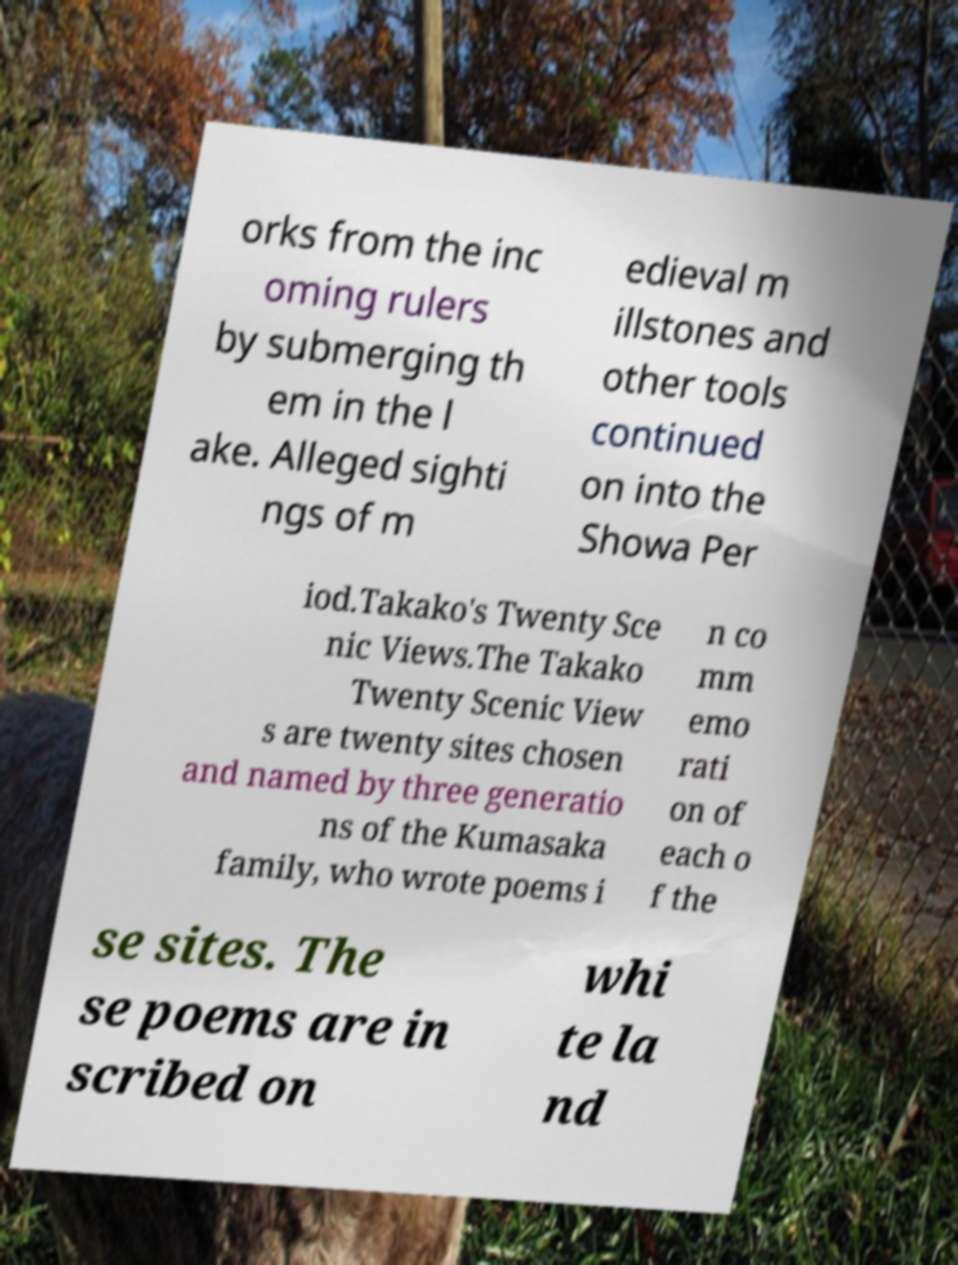Could you assist in decoding the text presented in this image and type it out clearly? orks from the inc oming rulers by submerging th em in the l ake. Alleged sighti ngs of m edieval m illstones and other tools continued on into the Showa Per iod.Takako's Twenty Sce nic Views.The Takako Twenty Scenic View s are twenty sites chosen and named by three generatio ns of the Kumasaka family, who wrote poems i n co mm emo rati on of each o f the se sites. The se poems are in scribed on whi te la nd 